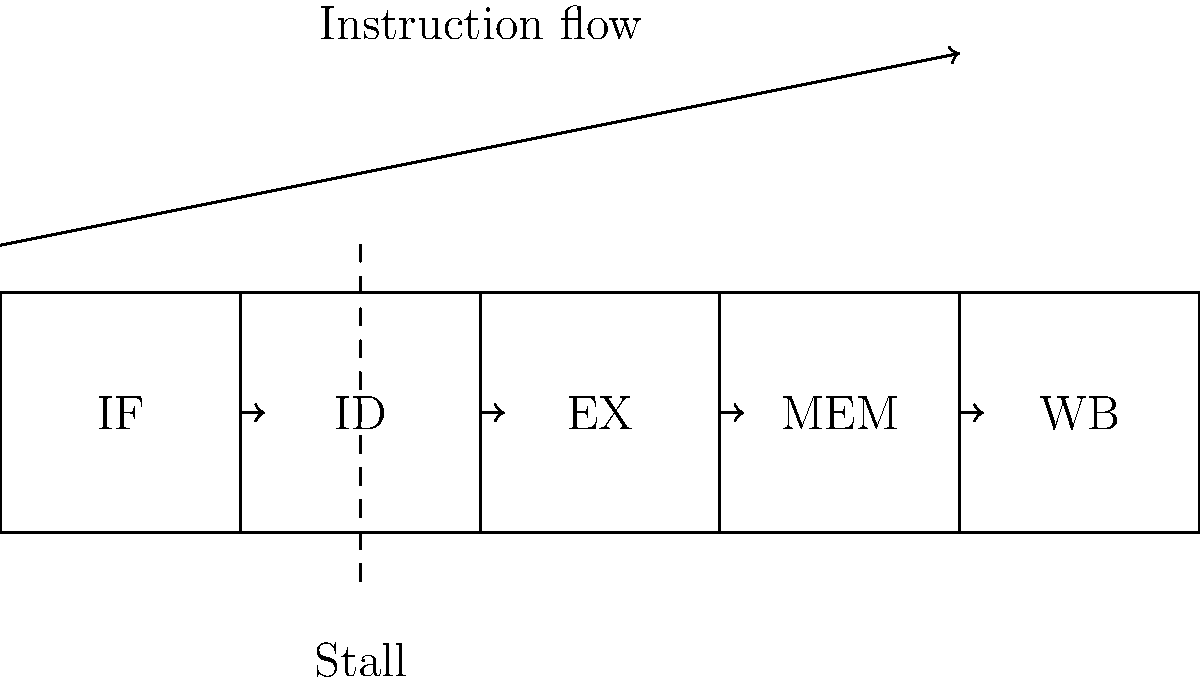In the given microprocessor pipeline diagram, which stage is most likely to cause a pipeline stall due to data hazards, and how can we optimize the pipeline to minimize such stalls? To answer this question, let's analyze the pipeline stages and their potential for causing data hazards:

1. IF (Instruction Fetch): Rarely causes data hazards.
2. ID (Instruction Decode): Can detect data hazards but doesn't cause them.
3. EX (Execute): Most likely to cause data hazards due to ALU operations.
4. MEM (Memory Access): Can cause data hazards, but less frequently than EX.
5. WB (Write Back): Rarely causes data hazards.

The EX stage is most likely to cause pipeline stalls due to data hazards. This is because:

a) Many instructions depend on the results of previous ALU operations.
b) The EX stage is where these operations are performed.
c) If an instruction needs data that hasn't been computed yet, it must stall.

To optimize the pipeline and minimize stalls:

1. Implement forwarding (bypassing): Allow the result of an operation to be used in the next cycle without waiting for the WB stage.
2. Use out-of-order execution: Execute instructions that don't depend on stalled data.
3. Employ branch prediction: Reduce stalls caused by control hazards.
4. Increase pipeline depth: More stages can reduce the impact of stalls but may increase overall latency.
5. Use dynamic scheduling: Reorder instructions to minimize stalls.

The most effective optimization depends on the specific workload and design constraints, but forwarding is generally the most efficient and widely used technique for minimizing data hazard stalls.
Answer: EX stage; implement forwarding 